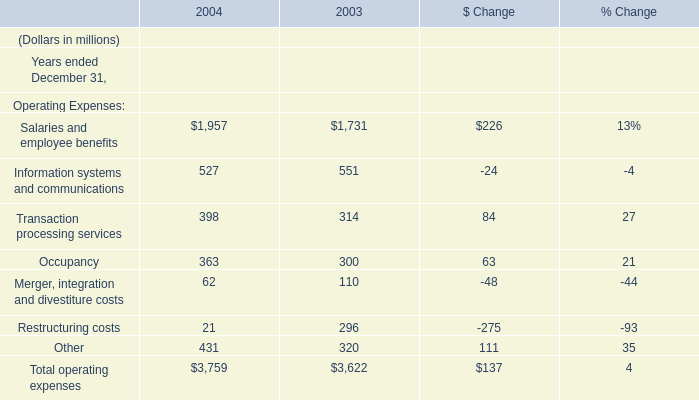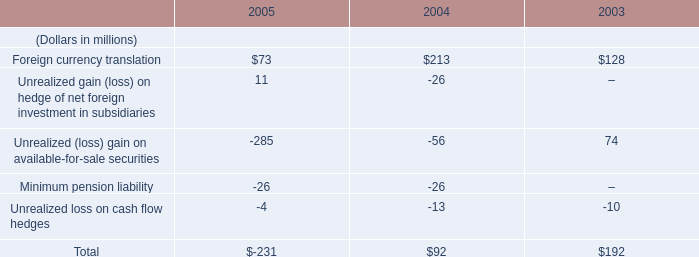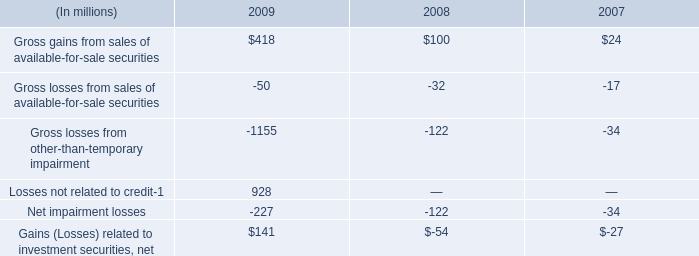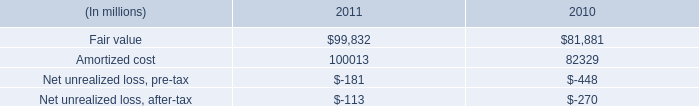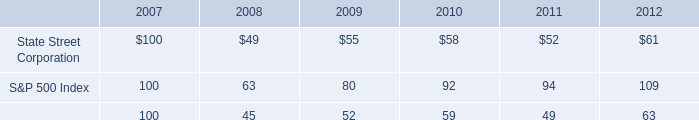What is the ratio of Operating Expenses:Occupancy to the total in 2003? 
Computations: (300 / 3622)
Answer: 0.08283. 